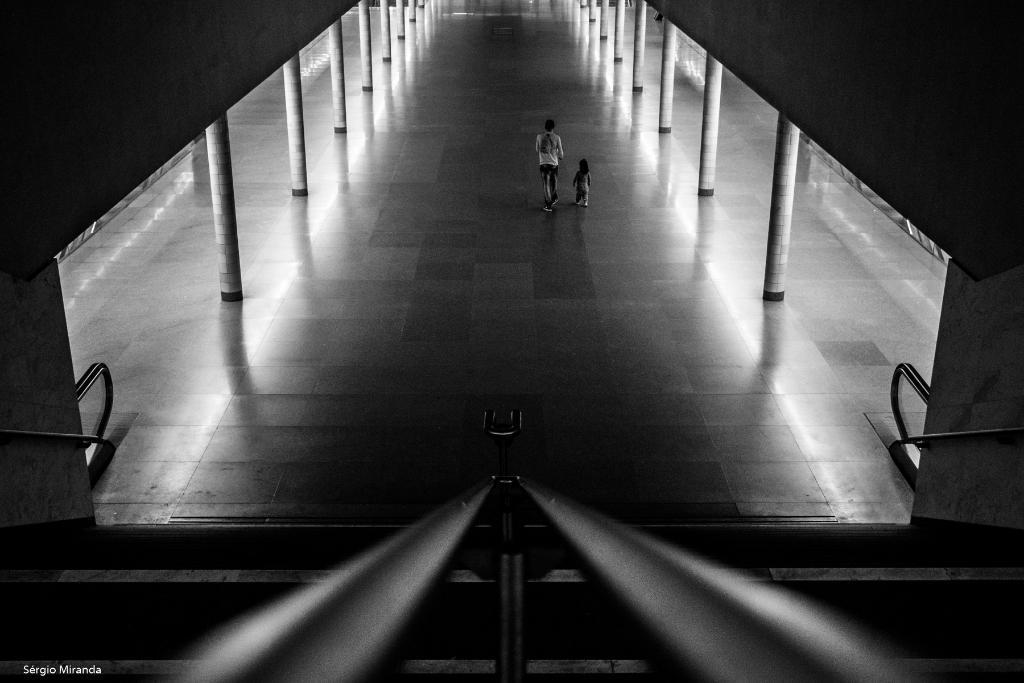Please provide a concise description of this image. In this image in the front there are railings, in the center there are persons walking. On the left side there are pillars and there is an object which is black in colour. On the right side there are pillars, there is a railing and there is an object which is black in colour. On the left side there is a railing on the wall and at the bottom left of the image there is some text which is visible. 